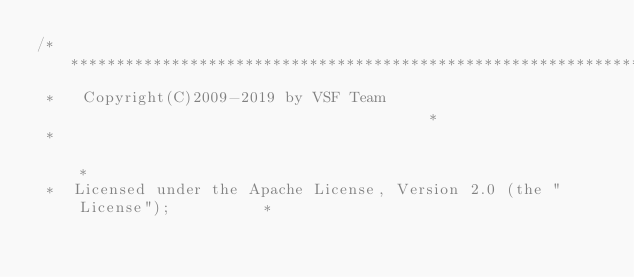<code> <loc_0><loc_0><loc_500><loc_500><_C_>/*****************************************************************************
 *   Copyright(C)2009-2019 by VSF Team                                       *
 *                                                                           *
 *  Licensed under the Apache License, Version 2.0 (the "License");          *</code> 